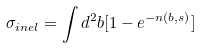<formula> <loc_0><loc_0><loc_500><loc_500>\sigma _ { i n e l } = \int d ^ { 2 } { b } [ 1 - e ^ { - n ( b , s ) } ]</formula> 